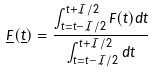Convert formula to latex. <formula><loc_0><loc_0><loc_500><loc_500>\underline { \tilde { F } } ( \underline { \tilde { t } } ) = \frac { \int _ { t = \tilde { t } - \mathcal { I } / 2 } ^ { \tilde { t } + \mathcal { I } / 2 } F ( t ) d t } { \int _ { t = \tilde { t } - \mathcal { I } / 2 } ^ { \tilde { t } + \mathcal { I } / 2 } d t } \\</formula> 